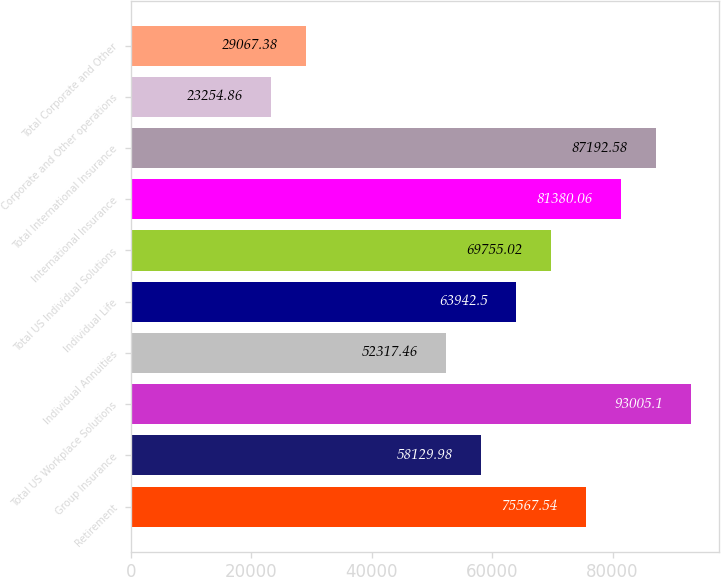<chart> <loc_0><loc_0><loc_500><loc_500><bar_chart><fcel>Retirement<fcel>Group Insurance<fcel>Total US Workplace Solutions<fcel>Individual Annuities<fcel>Individual Life<fcel>Total US Individual Solutions<fcel>International Insurance<fcel>Total International Insurance<fcel>Corporate and Other operations<fcel>Total Corporate and Other<nl><fcel>75567.5<fcel>58130<fcel>93005.1<fcel>52317.5<fcel>63942.5<fcel>69755<fcel>81380.1<fcel>87192.6<fcel>23254.9<fcel>29067.4<nl></chart> 